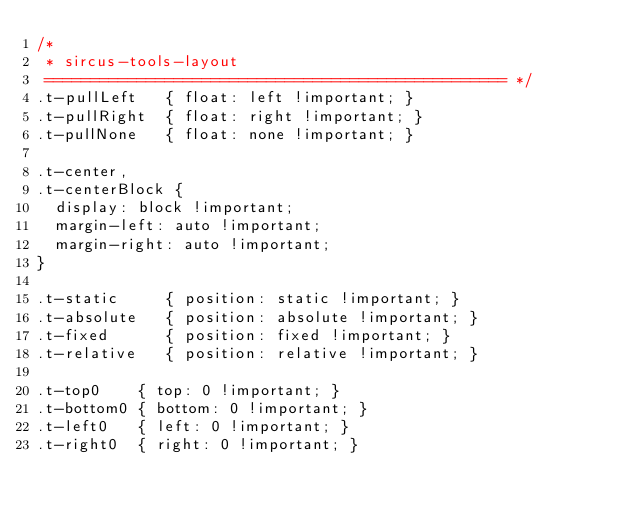Convert code to text. <code><loc_0><loc_0><loc_500><loc_500><_CSS_>/*
 * sircus-tools-layout
 ================================================== */
.t-pullLeft   { float: left !important; }
.t-pullRight  { float: right !important; }
.t-pullNone   { float: none !important; }

.t-center,
.t-centerBlock {
  display: block !important;
  margin-left: auto !important;
  margin-right: auto !important;
}

.t-static     { position: static !important; }
.t-absolute   { position: absolute !important; }
.t-fixed      { position: fixed !important; }
.t-relative   { position: relative !important; }

.t-top0    { top: 0 !important; }
.t-bottom0 { bottom: 0 !important; }
.t-left0   { left: 0 !important; }
.t-right0  { right: 0 !important; }
</code> 